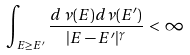<formula> <loc_0><loc_0><loc_500><loc_500>\int _ { E \geq E ^ { \prime } } \frac { d \, \nu ( E ) d \nu ( E ^ { \prime } ) } { | E - E ^ { \prime } | ^ { \gamma } } \, < \, \infty</formula> 